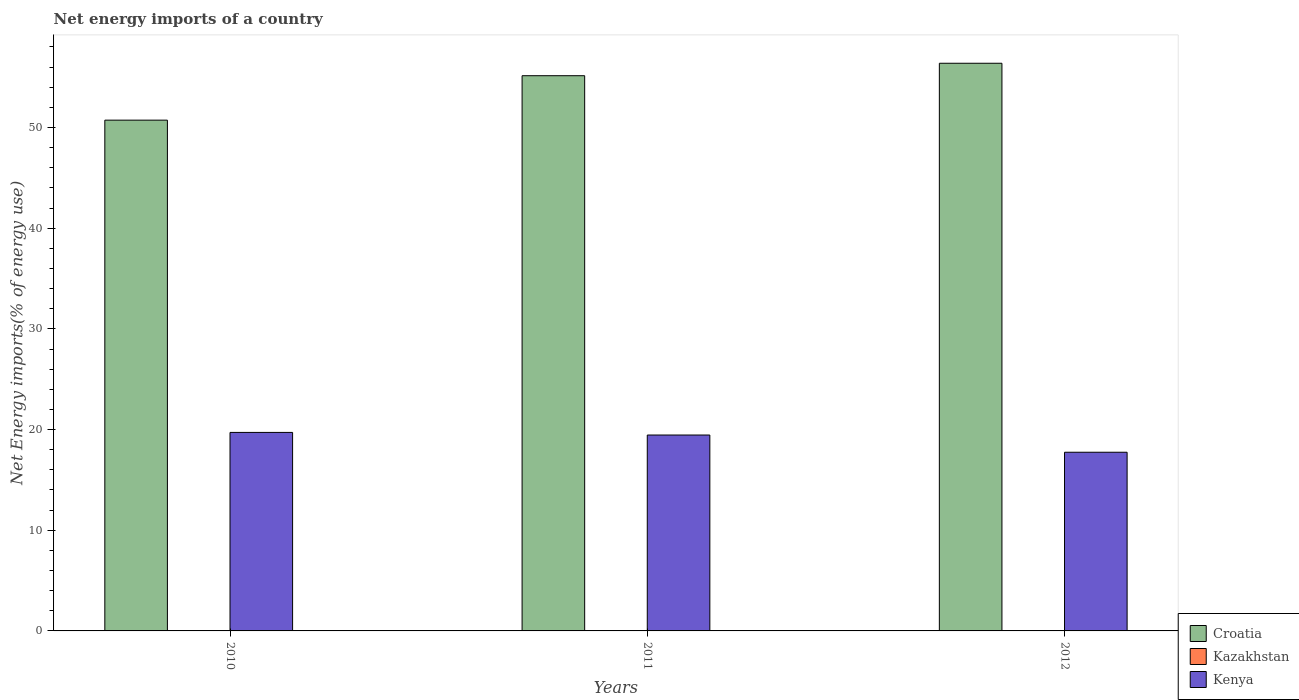How many different coloured bars are there?
Provide a succinct answer. 2. Are the number of bars per tick equal to the number of legend labels?
Provide a succinct answer. No. What is the label of the 3rd group of bars from the left?
Your answer should be very brief. 2012. In how many cases, is the number of bars for a given year not equal to the number of legend labels?
Offer a very short reply. 3. What is the net energy imports in Kazakhstan in 2012?
Offer a terse response. 0. Across all years, what is the maximum net energy imports in Kenya?
Offer a terse response. 19.72. Across all years, what is the minimum net energy imports in Croatia?
Your answer should be very brief. 50.73. What is the total net energy imports in Kenya in the graph?
Offer a terse response. 56.92. What is the difference between the net energy imports in Kenya in 2010 and that in 2011?
Provide a succinct answer. 0.26. What is the difference between the net energy imports in Kazakhstan in 2011 and the net energy imports in Kenya in 2012?
Your response must be concise. -17.75. What is the average net energy imports in Croatia per year?
Keep it short and to the point. 54.09. In the year 2011, what is the difference between the net energy imports in Croatia and net energy imports in Kenya?
Give a very brief answer. 35.69. In how many years, is the net energy imports in Kenya greater than 36 %?
Offer a very short reply. 0. What is the ratio of the net energy imports in Croatia in 2010 to that in 2011?
Give a very brief answer. 0.92. What is the difference between the highest and the second highest net energy imports in Kenya?
Provide a short and direct response. 0.26. What is the difference between the highest and the lowest net energy imports in Croatia?
Provide a succinct answer. 5.65. In how many years, is the net energy imports in Croatia greater than the average net energy imports in Croatia taken over all years?
Give a very brief answer. 2. Is the sum of the net energy imports in Croatia in 2010 and 2012 greater than the maximum net energy imports in Kazakhstan across all years?
Ensure brevity in your answer.  Yes. How many bars are there?
Provide a succinct answer. 6. What is the difference between two consecutive major ticks on the Y-axis?
Your response must be concise. 10. Are the values on the major ticks of Y-axis written in scientific E-notation?
Offer a terse response. No. Does the graph contain grids?
Offer a terse response. No. Where does the legend appear in the graph?
Provide a succinct answer. Bottom right. How many legend labels are there?
Make the answer very short. 3. What is the title of the graph?
Ensure brevity in your answer.  Net energy imports of a country. Does "United Arab Emirates" appear as one of the legend labels in the graph?
Provide a short and direct response. No. What is the label or title of the X-axis?
Your response must be concise. Years. What is the label or title of the Y-axis?
Give a very brief answer. Net Energy imports(% of energy use). What is the Net Energy imports(% of energy use) of Croatia in 2010?
Your answer should be very brief. 50.73. What is the Net Energy imports(% of energy use) in Kazakhstan in 2010?
Your response must be concise. 0. What is the Net Energy imports(% of energy use) in Kenya in 2010?
Provide a succinct answer. 19.72. What is the Net Energy imports(% of energy use) of Croatia in 2011?
Offer a terse response. 55.14. What is the Net Energy imports(% of energy use) in Kazakhstan in 2011?
Make the answer very short. 0. What is the Net Energy imports(% of energy use) in Kenya in 2011?
Offer a terse response. 19.46. What is the Net Energy imports(% of energy use) in Croatia in 2012?
Provide a succinct answer. 56.38. What is the Net Energy imports(% of energy use) of Kazakhstan in 2012?
Make the answer very short. 0. What is the Net Energy imports(% of energy use) of Kenya in 2012?
Give a very brief answer. 17.75. Across all years, what is the maximum Net Energy imports(% of energy use) of Croatia?
Your response must be concise. 56.38. Across all years, what is the maximum Net Energy imports(% of energy use) of Kenya?
Provide a short and direct response. 19.72. Across all years, what is the minimum Net Energy imports(% of energy use) of Croatia?
Keep it short and to the point. 50.73. Across all years, what is the minimum Net Energy imports(% of energy use) of Kenya?
Offer a terse response. 17.75. What is the total Net Energy imports(% of energy use) in Croatia in the graph?
Make the answer very short. 162.26. What is the total Net Energy imports(% of energy use) in Kenya in the graph?
Give a very brief answer. 56.92. What is the difference between the Net Energy imports(% of energy use) of Croatia in 2010 and that in 2011?
Provide a short and direct response. -4.41. What is the difference between the Net Energy imports(% of energy use) in Kenya in 2010 and that in 2011?
Your answer should be very brief. 0.26. What is the difference between the Net Energy imports(% of energy use) of Croatia in 2010 and that in 2012?
Keep it short and to the point. -5.65. What is the difference between the Net Energy imports(% of energy use) of Kenya in 2010 and that in 2012?
Ensure brevity in your answer.  1.97. What is the difference between the Net Energy imports(% of energy use) in Croatia in 2011 and that in 2012?
Provide a succinct answer. -1.24. What is the difference between the Net Energy imports(% of energy use) of Kenya in 2011 and that in 2012?
Offer a terse response. 1.71. What is the difference between the Net Energy imports(% of energy use) in Croatia in 2010 and the Net Energy imports(% of energy use) in Kenya in 2011?
Your response must be concise. 31.27. What is the difference between the Net Energy imports(% of energy use) in Croatia in 2010 and the Net Energy imports(% of energy use) in Kenya in 2012?
Give a very brief answer. 32.98. What is the difference between the Net Energy imports(% of energy use) in Croatia in 2011 and the Net Energy imports(% of energy use) in Kenya in 2012?
Give a very brief answer. 37.4. What is the average Net Energy imports(% of energy use) of Croatia per year?
Your response must be concise. 54.09. What is the average Net Energy imports(% of energy use) of Kazakhstan per year?
Ensure brevity in your answer.  0. What is the average Net Energy imports(% of energy use) of Kenya per year?
Offer a terse response. 18.97. In the year 2010, what is the difference between the Net Energy imports(% of energy use) of Croatia and Net Energy imports(% of energy use) of Kenya?
Your answer should be compact. 31.01. In the year 2011, what is the difference between the Net Energy imports(% of energy use) in Croatia and Net Energy imports(% of energy use) in Kenya?
Ensure brevity in your answer.  35.69. In the year 2012, what is the difference between the Net Energy imports(% of energy use) of Croatia and Net Energy imports(% of energy use) of Kenya?
Make the answer very short. 38.63. What is the ratio of the Net Energy imports(% of energy use) of Kenya in 2010 to that in 2011?
Offer a very short reply. 1.01. What is the ratio of the Net Energy imports(% of energy use) in Croatia in 2010 to that in 2012?
Provide a succinct answer. 0.9. What is the ratio of the Net Energy imports(% of energy use) in Kenya in 2010 to that in 2012?
Offer a terse response. 1.11. What is the ratio of the Net Energy imports(% of energy use) of Croatia in 2011 to that in 2012?
Your answer should be very brief. 0.98. What is the ratio of the Net Energy imports(% of energy use) in Kenya in 2011 to that in 2012?
Provide a short and direct response. 1.1. What is the difference between the highest and the second highest Net Energy imports(% of energy use) of Croatia?
Keep it short and to the point. 1.24. What is the difference between the highest and the second highest Net Energy imports(% of energy use) of Kenya?
Your answer should be compact. 0.26. What is the difference between the highest and the lowest Net Energy imports(% of energy use) of Croatia?
Offer a very short reply. 5.65. What is the difference between the highest and the lowest Net Energy imports(% of energy use) in Kenya?
Make the answer very short. 1.97. 